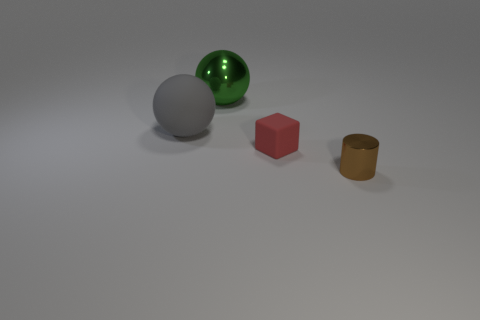Add 2 tiny blocks. How many objects exist? 6 Subtract all cubes. How many objects are left? 3 Subtract 0 green blocks. How many objects are left? 4 Subtract all blue balls. Subtract all large rubber things. How many objects are left? 3 Add 3 red matte cubes. How many red matte cubes are left? 4 Add 1 small brown metal cylinders. How many small brown metal cylinders exist? 2 